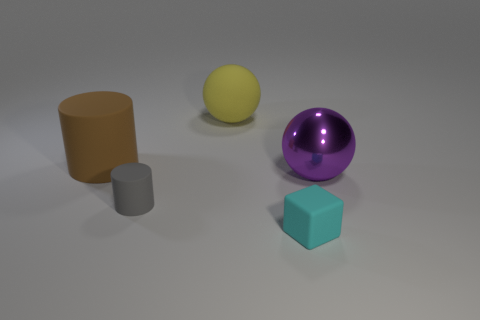What size is the matte thing that is in front of the cylinder on the right side of the brown cylinder? The matte object in front of the cylinder on the right side of the brown cylinder appears to be small in size, specifically a small gray cylinder that is significantly shorter than the brown cylinder beside it. 